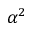Convert formula to latex. <formula><loc_0><loc_0><loc_500><loc_500>\alpha ^ { 2 }</formula> 